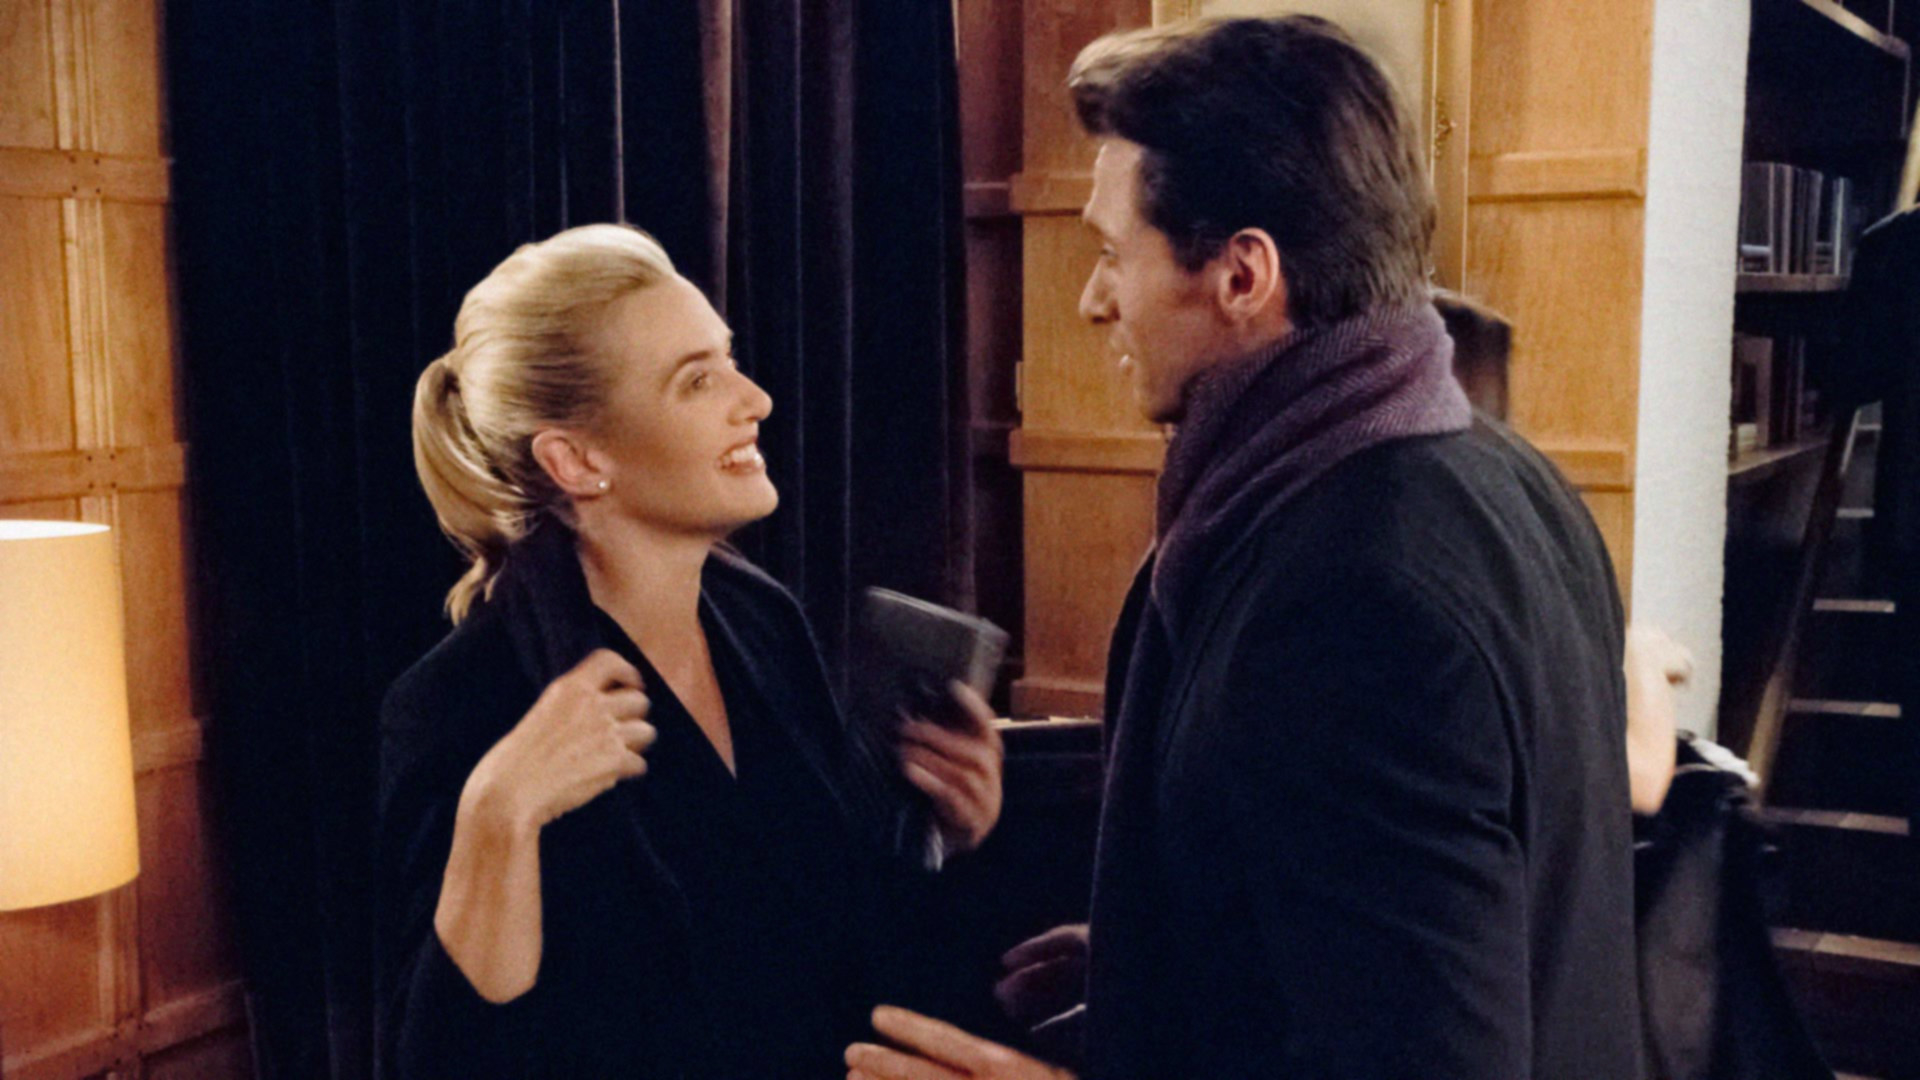What do you think is going on in this snapshot? The image shows two individuals engrossed in what appears to be a friendly conversation in an indoor setting that resembles a library or home study. The woman, wearing an elegant dark coat and styled hair in a bun, seems to share a light-hearted moment with the man, who is casually holding a book and dressed in a scarf and gray coat. Their expressions suggest familiarity and comfort in each other's company, implying a possible intellectual exchange or a moment of reprieve in a narrative context. 